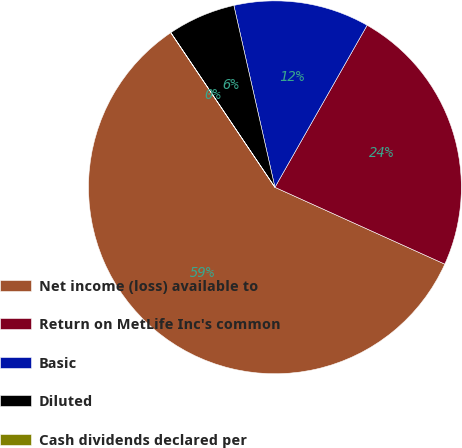Convert chart. <chart><loc_0><loc_0><loc_500><loc_500><pie_chart><fcel>Net income (loss) available to<fcel>Return on MetLife Inc's common<fcel>Basic<fcel>Diluted<fcel>Cash dividends declared per<nl><fcel>58.81%<fcel>23.53%<fcel>11.77%<fcel>5.89%<fcel>0.01%<nl></chart> 